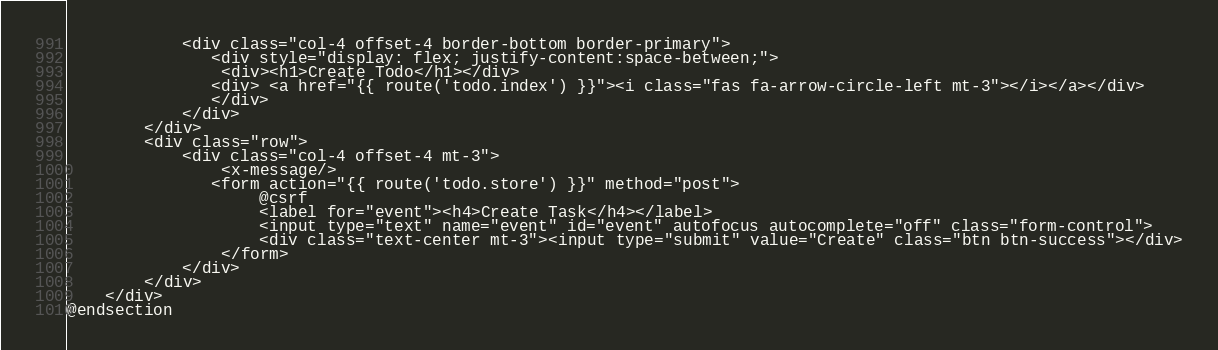Convert code to text. <code><loc_0><loc_0><loc_500><loc_500><_PHP_>            <div class="col-4 offset-4 border-bottom border-primary">
               <div style="display: flex; justify-content:space-between;">
                <div><h1>Create Todo</h1></div>
               <div> <a href="{{ route('todo.index') }}"><i class="fas fa-arrow-circle-left mt-3"></i></a></div>
               </div>
            </div>
        </div>
        <div class="row">
            <div class="col-4 offset-4 mt-3">
                <x-message/>
               <form action="{{ route('todo.store') }}" method="post">
                    @csrf
                    <label for="event"><h4>Create Task</h4></label>
                    <input type="text" name="event" id="event" autofocus autocomplete="off" class="form-control">
                    <div class="text-center mt-3"><input type="submit" value="Create" class="btn btn-success"></div>
                </form>
            </div>
        </div>
    </div>
@endsection  </code> 